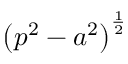<formula> <loc_0><loc_0><loc_500><loc_500>\left ( p ^ { 2 } - a ^ { 2 } \right ) ^ { \frac { 1 } { 2 } }</formula> 